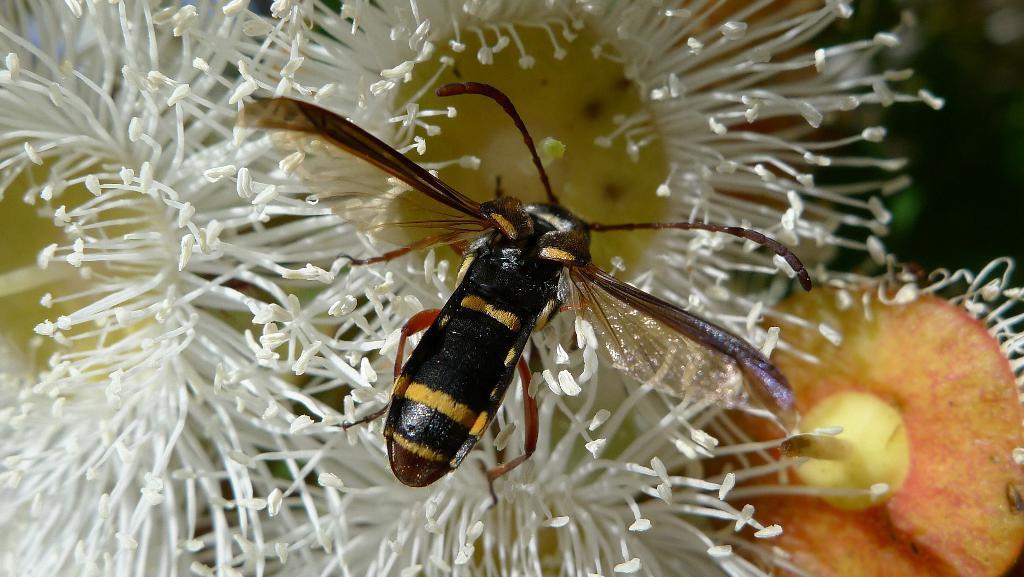Can you describe this image briefly? In this picture I can see an insect in front, which is of black, yellow and brown in color. In the background I can see the flowers which are of white, yellow and orange color. 